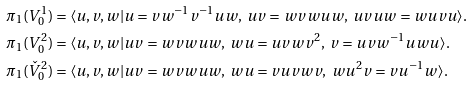<formula> <loc_0><loc_0><loc_500><loc_500>\pi _ { 1 } ( V ^ { 1 } _ { 0 } ) & = \langle u , v , w | u = v w ^ { - 1 } v ^ { - 1 } u w , \ u v = w v w u w , \ u v u w = w u v u \rangle . \\ \pi _ { 1 } ( V ^ { 2 } _ { 0 } ) & = \langle u , v , w | u v = w v w u w , \ w u = u v w v ^ { 2 } , \ v = u v w ^ { - 1 } u w u \rangle . \\ \pi _ { 1 } ( \check { V } ^ { 2 } _ { 0 } ) & = \langle u , v , w | u v = w v w u w , \ w u = v u v w v , \ w u ^ { 2 } v = v u ^ { - 1 } w \rangle .</formula> 